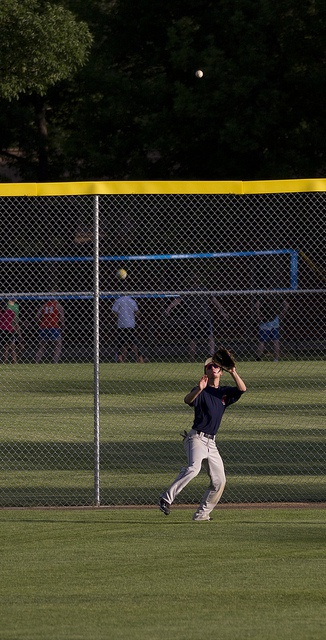Describe the objects in this image and their specific colors. I can see people in darkgreen, black, darkgray, and gray tones, people in darkgreen, black, and gray tones, people in darkgreen, black, and gray tones, people in darkgreen, black, gray, and darkblue tones, and people in darkgreen, black, gray, and maroon tones in this image. 